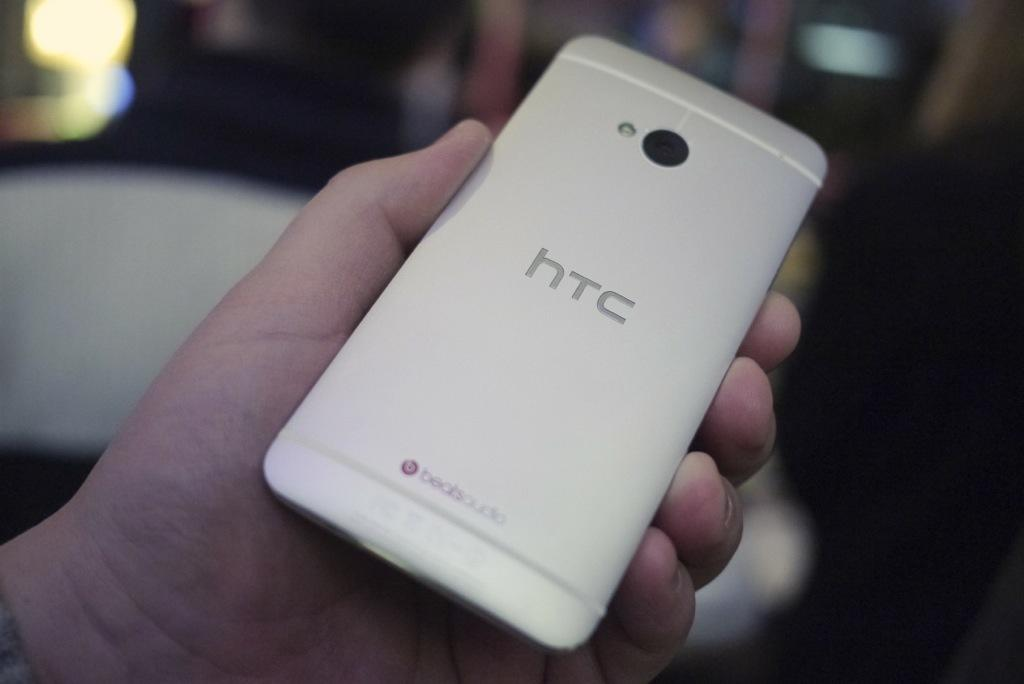<image>
Create a compact narrative representing the image presented. a white htc phone in someones hand showing the camera and backlight 